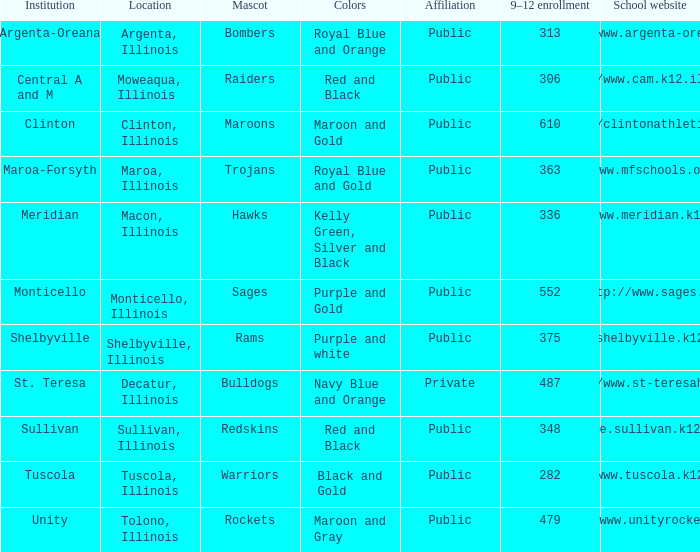What colors can you see players from Tolono, Illinois wearing? Maroon and Gray. I'm looking to parse the entire table for insights. Could you assist me with that? {'header': ['Institution', 'Location', 'Mascot', 'Colors', 'Affiliation', '9–12 enrollment', 'School website'], 'rows': [['Argenta-Oreana', 'Argenta, Illinois', 'Bombers', 'Royal Blue and Orange', 'Public', '313', 'http://www.argenta-oreana.org'], ['Central A and M', 'Moweaqua, Illinois', 'Raiders', 'Red and Black', 'Public', '306', 'http://www.cam.k12.il.us/hs'], ['Clinton', 'Clinton, Illinois', 'Maroons', 'Maroon and Gold', 'Public', '610', 'http://clintonathletics.com'], ['Maroa-Forsyth', 'Maroa, Illinois', 'Trojans', 'Royal Blue and Gold', 'Public', '363', 'http://www.mfschools.org/high/'], ['Meridian', 'Macon, Illinois', 'Hawks', 'Kelly Green, Silver and Black', 'Public', '336', 'http://www.meridian.k12.il.us/'], ['Monticello', 'Monticello, Illinois', 'Sages', 'Purple and Gold', 'Public', '552', 'http://www.sages.us'], ['Shelbyville', 'Shelbyville, Illinois', 'Rams', 'Purple and white', 'Public', '375', 'http://shelbyville.k12.il.us/'], ['St. Teresa', 'Decatur, Illinois', 'Bulldogs', 'Navy Blue and Orange', 'Private', '487', 'http://www.st-teresahs.org/'], ['Sullivan', 'Sullivan, Illinois', 'Redskins', 'Red and Black', 'Public', '348', 'http://home.sullivan.k12.il.us/shs'], ['Tuscola', 'Tuscola, Illinois', 'Warriors', 'Black and Gold', 'Public', '282', 'http://www.tuscola.k12.il.us/'], ['Unity', 'Tolono, Illinois', 'Rockets', 'Maroon and Gray', 'Public', '479', 'http://www.unityrockets.com/']]} 